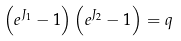Convert formula to latex. <formula><loc_0><loc_0><loc_500><loc_500>\left ( e ^ { J _ { 1 } } - 1 \right ) \left ( e ^ { J _ { 2 } } - 1 \right ) = q</formula> 